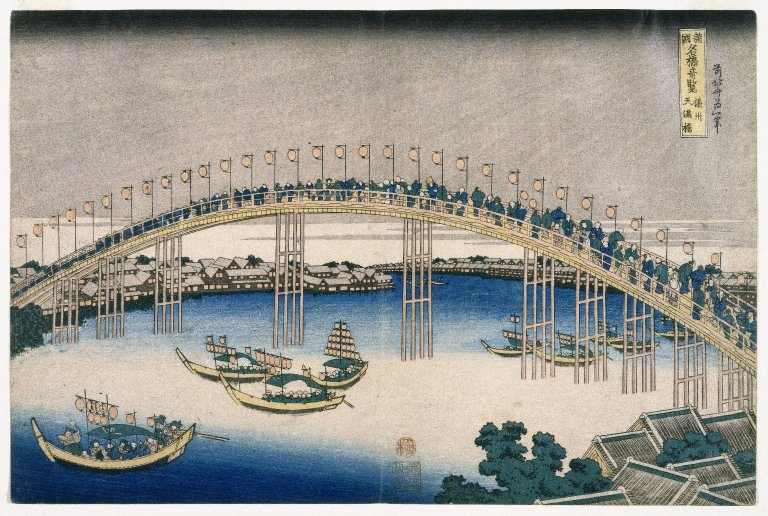What might the presence of the boats and the busy bridge suggest about this place during the time? The presence of numerous boats and the crowded nature of Ryōgoku Bridge suggest a thriving, economically vital area. During the Edo period, waterways were crucial for transportation and trade, indicative of a prosperous marketplace. The bridge itself not only served as a physical link between multiple districts of Tokyo but also as a social and cultural gathering place, likely drawing vendors, entertainers, and townspeople, thereby highlighting the bustling, interconnected nature of urban life in historical Japan. 